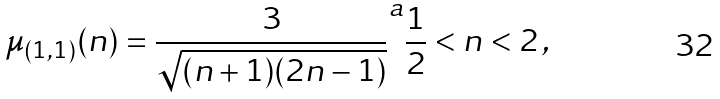Convert formula to latex. <formula><loc_0><loc_0><loc_500><loc_500>\mu _ { ( 1 , 1 ) } ( n ) = \frac { 3 } { \sqrt { ( n + 1 ) ( 2 n - 1 ) } } ^ { a } \frac { 1 } { 2 } < n < 2 \, ,</formula> 